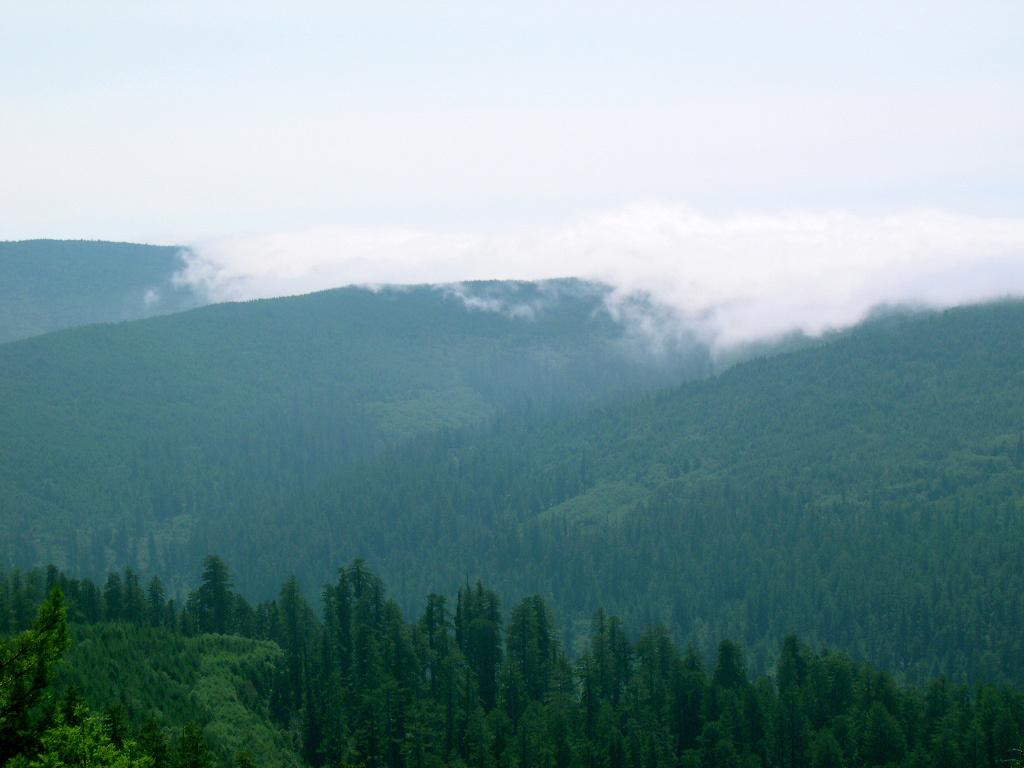What type of natural elements can be seen in the image? There are trees and hills visible in the image. What atmospheric condition is present in the image? There is fog visible in the image. How many beds can be seen in the image? There are no beds present in the image. What type of sand is visible in the image? There is no sand visible in the image. 